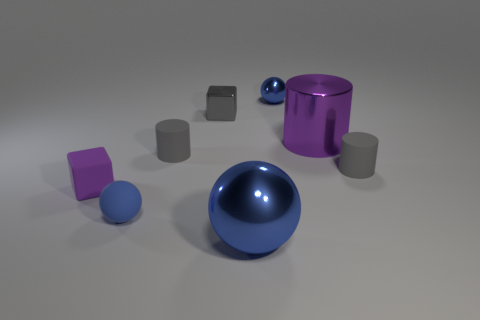How many blue spheres must be subtracted to get 1 blue spheres? 2 Subtract all blocks. How many objects are left? 6 Subtract 2 balls. How many balls are left? 1 Subtract all purple blocks. Subtract all red spheres. How many blocks are left? 1 Subtract all gray spheres. How many gray cylinders are left? 2 Subtract all blue metal balls. Subtract all big brown metallic balls. How many objects are left? 6 Add 5 purple shiny objects. How many purple shiny objects are left? 6 Add 2 purple things. How many purple things exist? 4 Add 1 tiny blue shiny spheres. How many objects exist? 9 Subtract all purple cylinders. How many cylinders are left? 2 